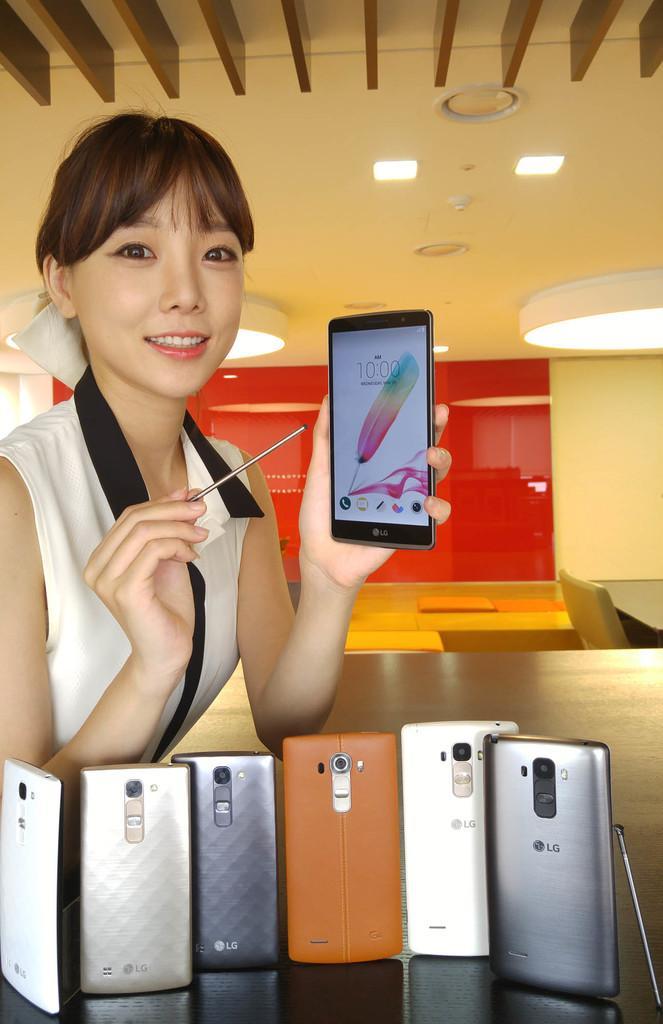Describe this image in one or two sentences. In this image I can see so many mobiles and a person holding the mobile. 